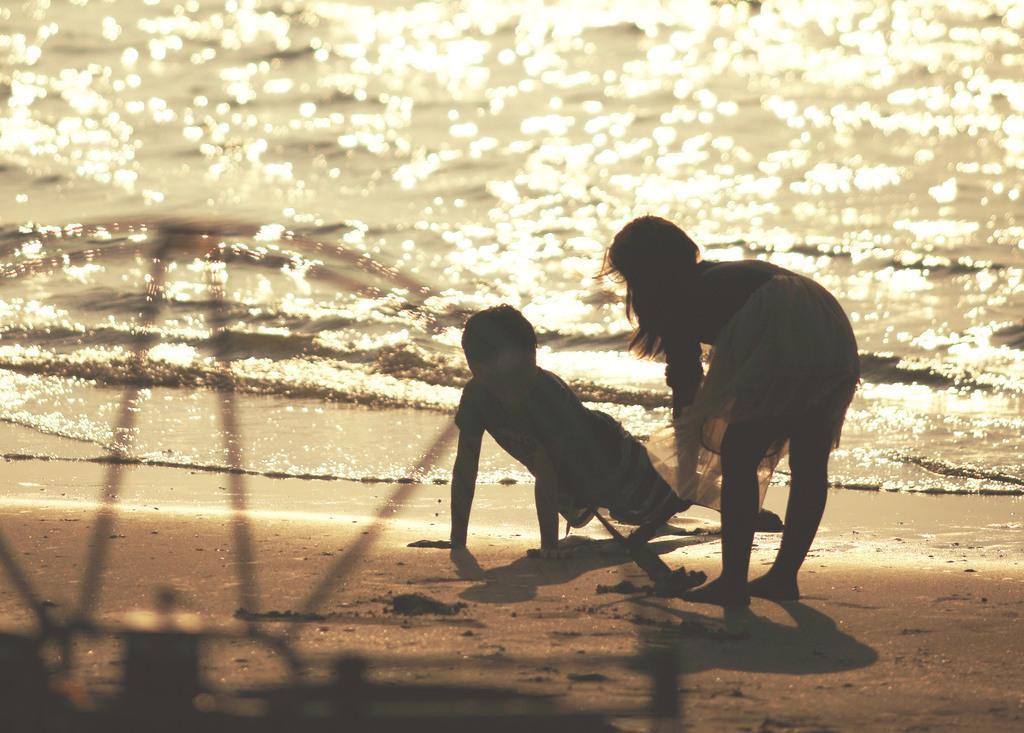Please provide a concise description of this image. In this image, we can see kids and at the bottom, there is water and sand. 